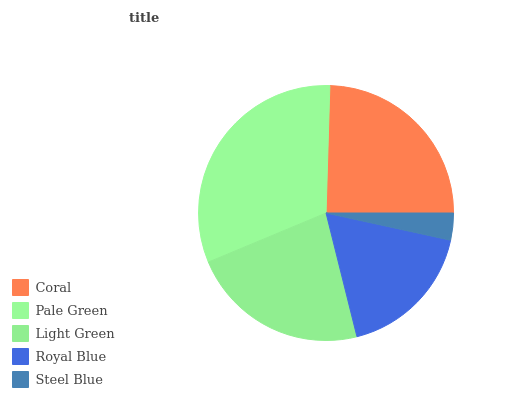Is Steel Blue the minimum?
Answer yes or no. Yes. Is Pale Green the maximum?
Answer yes or no. Yes. Is Light Green the minimum?
Answer yes or no. No. Is Light Green the maximum?
Answer yes or no. No. Is Pale Green greater than Light Green?
Answer yes or no. Yes. Is Light Green less than Pale Green?
Answer yes or no. Yes. Is Light Green greater than Pale Green?
Answer yes or no. No. Is Pale Green less than Light Green?
Answer yes or no. No. Is Light Green the high median?
Answer yes or no. Yes. Is Light Green the low median?
Answer yes or no. Yes. Is Royal Blue the high median?
Answer yes or no. No. Is Pale Green the low median?
Answer yes or no. No. 